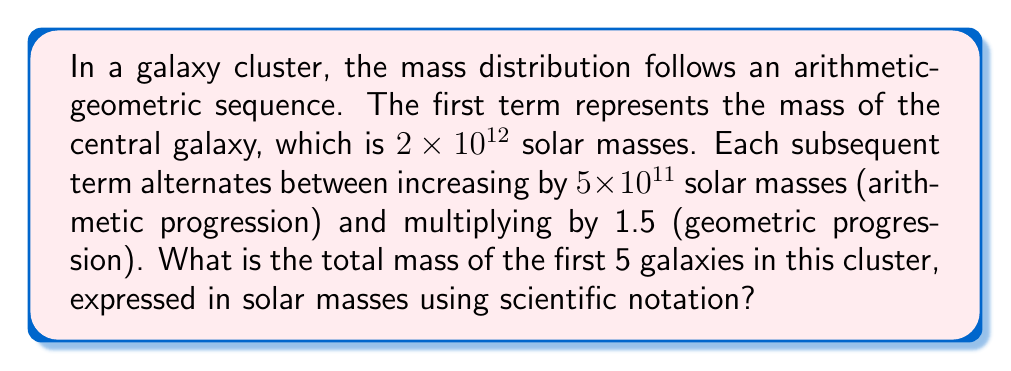Teach me how to tackle this problem. Let's approach this step-by-step:

1) First, let's write out the sequence for the first 5 terms:

   $a_1 = 2 \times 10^{12}$ (given)
   
   $a_2 = a_1 + 5 \times 10^{11} = 2.5 \times 10^{12}$
   
   $a_3 = a_2 \times 1.5 = 3.75 \times 10^{12}$
   
   $a_4 = a_3 + 5 \times 10^{11} = 4.25 \times 10^{12}$
   
   $a_5 = a_4 \times 1.5 = 6.375 \times 10^{12}$

2) Now, we need to sum these terms:

   $S_5 = a_1 + a_2 + a_3 + a_4 + a_5$

3) Substituting the values:

   $S_5 = (2 + 2.5 + 3.75 + 4.25 + 6.375) \times 10^{12}$

4) Adding these numbers:

   $S_5 = 18.875 \times 10^{12}$

5) Expressing in scientific notation:

   $S_5 = 1.8875 \times 10^{13}$

Therefore, the total mass of the first 5 galaxies in this cluster is $1.8875 \times 10^{13}$ solar masses.
Answer: $1.8875 \times 10^{13}$ solar masses 